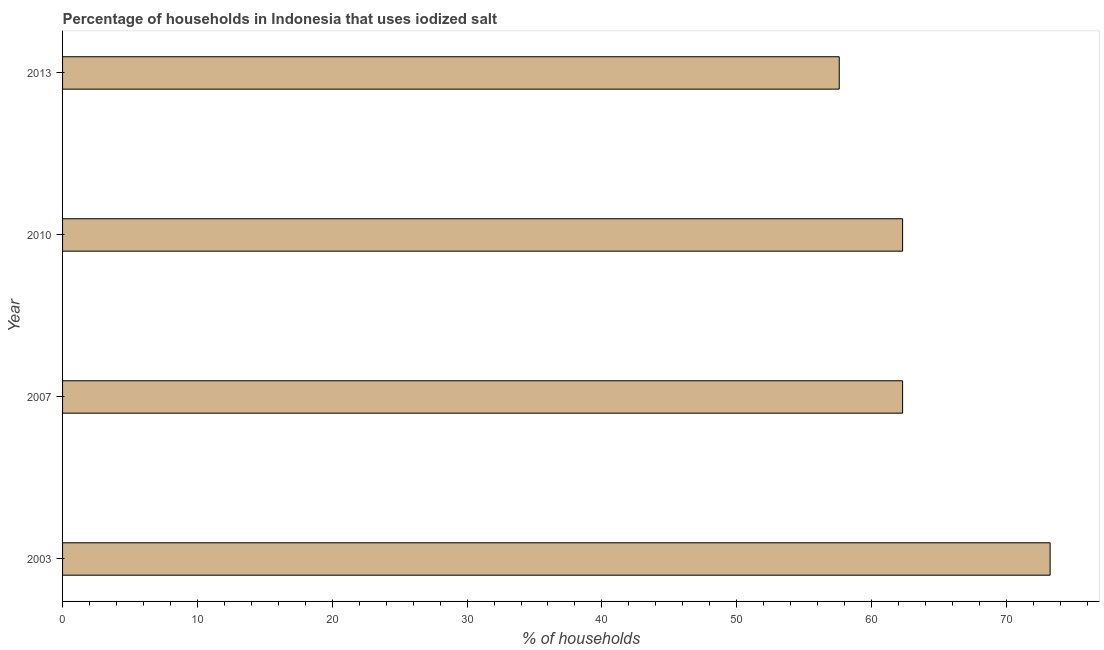Does the graph contain any zero values?
Offer a very short reply. No. What is the title of the graph?
Offer a terse response. Percentage of households in Indonesia that uses iodized salt. What is the label or title of the X-axis?
Offer a terse response. % of households. What is the percentage of households where iodized salt is consumed in 2007?
Offer a terse response. 62.3. Across all years, what is the maximum percentage of households where iodized salt is consumed?
Provide a short and direct response. 73.24. Across all years, what is the minimum percentage of households where iodized salt is consumed?
Your response must be concise. 57.6. In which year was the percentage of households where iodized salt is consumed maximum?
Your answer should be very brief. 2003. What is the sum of the percentage of households where iodized salt is consumed?
Ensure brevity in your answer.  255.44. What is the difference between the percentage of households where iodized salt is consumed in 2003 and 2007?
Give a very brief answer. 10.94. What is the average percentage of households where iodized salt is consumed per year?
Your answer should be very brief. 63.86. What is the median percentage of households where iodized salt is consumed?
Offer a terse response. 62.3. What is the ratio of the percentage of households where iodized salt is consumed in 2007 to that in 2010?
Give a very brief answer. 1. Is the percentage of households where iodized salt is consumed in 2007 less than that in 2010?
Your answer should be very brief. No. Is the difference between the percentage of households where iodized salt is consumed in 2010 and 2013 greater than the difference between any two years?
Provide a short and direct response. No. What is the difference between the highest and the second highest percentage of households where iodized salt is consumed?
Provide a short and direct response. 10.94. Is the sum of the percentage of households where iodized salt is consumed in 2003 and 2010 greater than the maximum percentage of households where iodized salt is consumed across all years?
Provide a short and direct response. Yes. What is the difference between the highest and the lowest percentage of households where iodized salt is consumed?
Provide a short and direct response. 15.64. What is the difference between two consecutive major ticks on the X-axis?
Offer a very short reply. 10. What is the % of households of 2003?
Your answer should be compact. 73.24. What is the % of households of 2007?
Your response must be concise. 62.3. What is the % of households of 2010?
Provide a succinct answer. 62.3. What is the % of households in 2013?
Make the answer very short. 57.6. What is the difference between the % of households in 2003 and 2007?
Give a very brief answer. 10.94. What is the difference between the % of households in 2003 and 2010?
Your answer should be compact. 10.94. What is the difference between the % of households in 2003 and 2013?
Your answer should be very brief. 15.64. What is the difference between the % of households in 2007 and 2010?
Your response must be concise. 0. What is the difference between the % of households in 2007 and 2013?
Provide a short and direct response. 4.7. What is the difference between the % of households in 2010 and 2013?
Your response must be concise. 4.7. What is the ratio of the % of households in 2003 to that in 2007?
Your answer should be compact. 1.18. What is the ratio of the % of households in 2003 to that in 2010?
Offer a very short reply. 1.18. What is the ratio of the % of households in 2003 to that in 2013?
Make the answer very short. 1.27. What is the ratio of the % of households in 2007 to that in 2010?
Offer a very short reply. 1. What is the ratio of the % of households in 2007 to that in 2013?
Ensure brevity in your answer.  1.08. What is the ratio of the % of households in 2010 to that in 2013?
Offer a terse response. 1.08. 